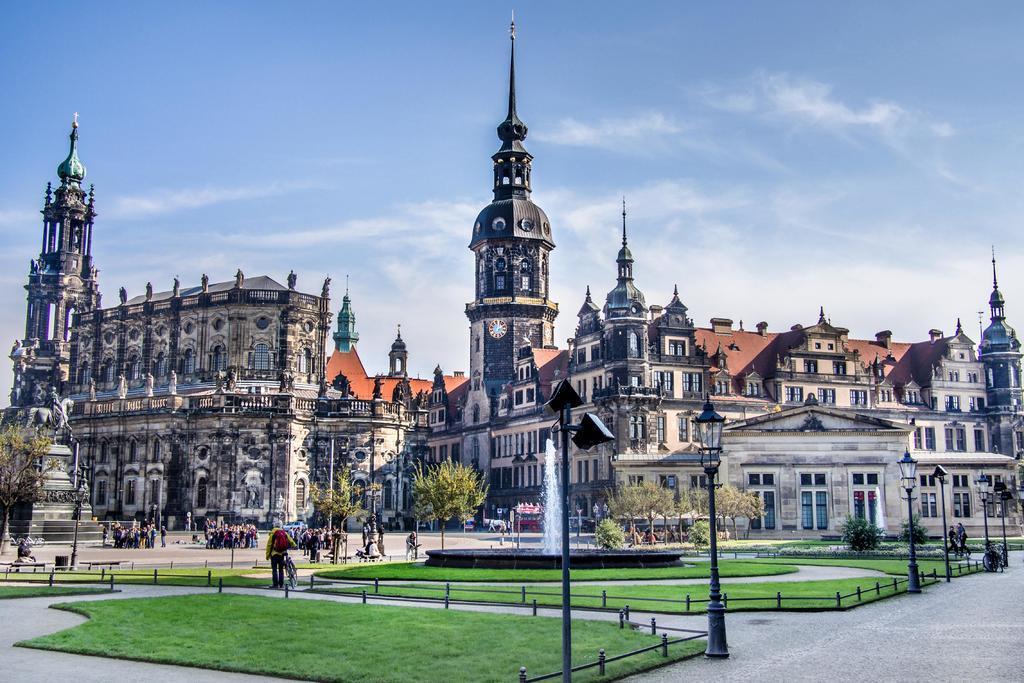Describe this image in one or two sentences. At the bottom of the image on the floor there are few places with grass. Around the grass there is fencing and also there are poles with lamps. And also there is a fountain. On the right side of the image on the pedestal there is a statue of a person sitting on a horse. In front of the statue there are many people standing. In the game there are few plants, trees and bushes. In the background there are buildings. At the top of the image there is sky. 